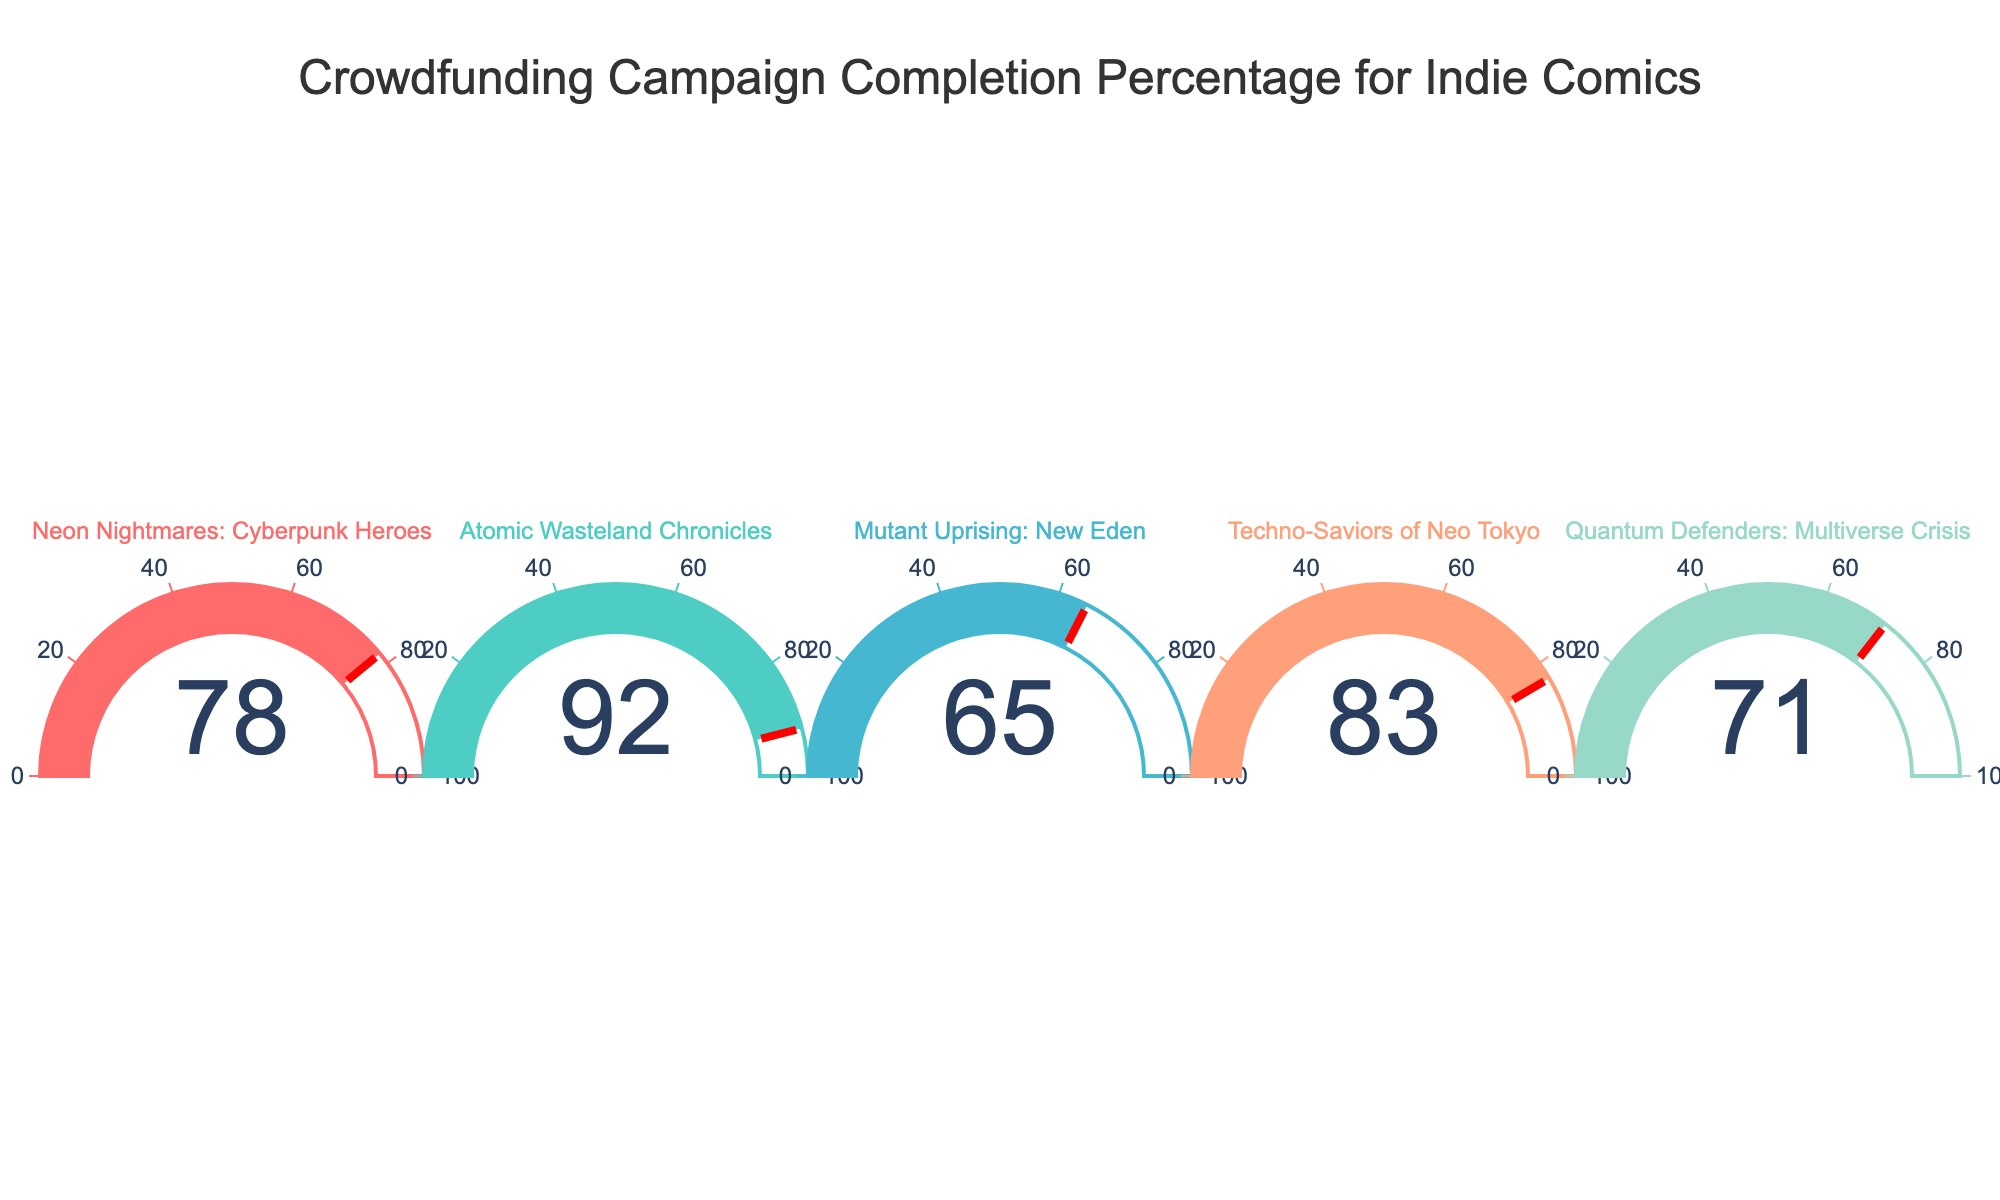what is the title of the figure? The title of the figure is often found at the top of the plot. For this specific plot, it is clearly mentioned.
Answer: Crowdfunding Campaign Completion Percentage for Indie Comics how many campaigns are represented in the figure? Counting the number of gauges in the plot will give us the number of campaigns.
Answer: 5 which campaign has the highest completion percentage? By looking at the values displayed on the gauges, we can identify the campaign with the highest number.
Answer: Atomic Wasteland Chronicles what is the completion percentage for Neon Nightmares: Cyberpunk Heroes? The gauge for "Neon Nightmares: Cyberpunk Heroes" shows the completion percentage directly.
Answer: 78% what is the average completion percentage of all campaigns? First, sum the completion percentages: 78 + 92 + 65 + 83 + 71 = 389. Then, divide by the number of campaigns, which is 5. 389 ÷ 5 = 77.8.
Answer: 77.8% which campaign has the lowest completion percentage? By examining the values, find the lowest one among the displayed gauges.
Answer: Mutant Uprising: New Eden what is the difference between the highest and the lowest completion percentages? Subtract the lowest completion percentage from the highest one. 92 - 65 = 27.
Answer: 27% which campaign's completion percentage is closer to the average? The average completion percentage is 77.8%. Compare each campaign's percentage to this value and find the closest one. "Techno-Saviors of Neo Tokyo" has a completion percentage of 83, which is 5.2 higher, and "Neon Nightmares: Cyberpunk Heroes" has 78, which is 0.2 higher.
Answer: Neon Nightmares: Cyberpunk Heroes what color is used for the gauge of Quantum Defenders: Multiverse Crisis? Each gauge is associated with a specific color. Look for the color of the gauge belonging to "Quantum Defenders: Multiverse Crisis."
Answer: Light blue which campaigns have a completion percentage above 80%? Identify the campaigns with gauges showing values greater than 80.
Answer: Atomic Wasteland Chronicles, Techno-Saviors of Neo Tokyo 